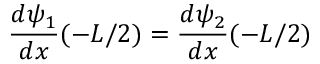<formula> <loc_0><loc_0><loc_500><loc_500>{ \frac { d \psi _ { 1 } } { d x } } ( - L / 2 ) = { \frac { d \psi _ { 2 } } { d x } } ( - L / 2 ) \,</formula> 